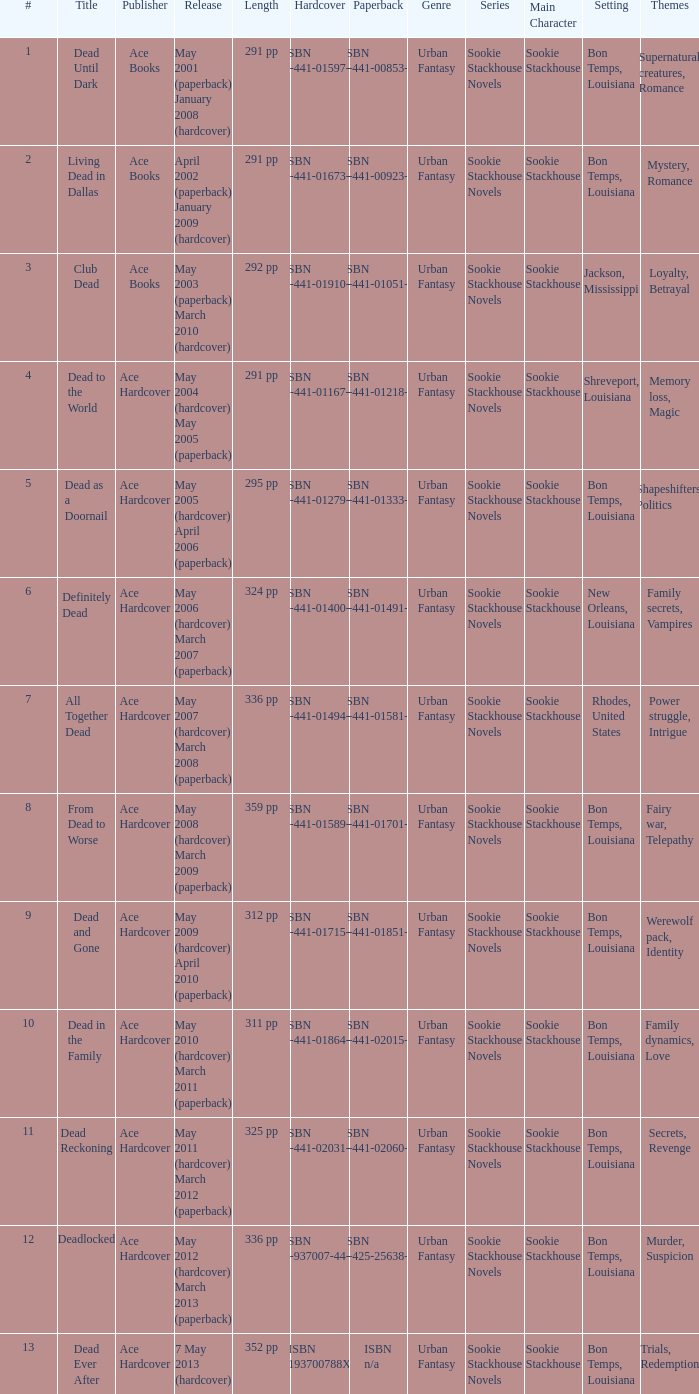What is the book number associated with isbn 0-441-01400-3? 6.0. 